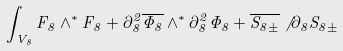<formula> <loc_0><loc_0><loc_500><loc_500>\int _ { V _ { 8 } } F _ { 8 } \wedge ^ { * } F _ { 8 } + \partial _ { 8 } ^ { 2 } \overline { \Phi _ { 8 } } \wedge ^ { * } \partial _ { 8 } ^ { 2 } \Phi _ { 8 } + \overline { S _ { 8 \pm } } \not \, \partial _ { 8 } S _ { 8 \pm }</formula> 